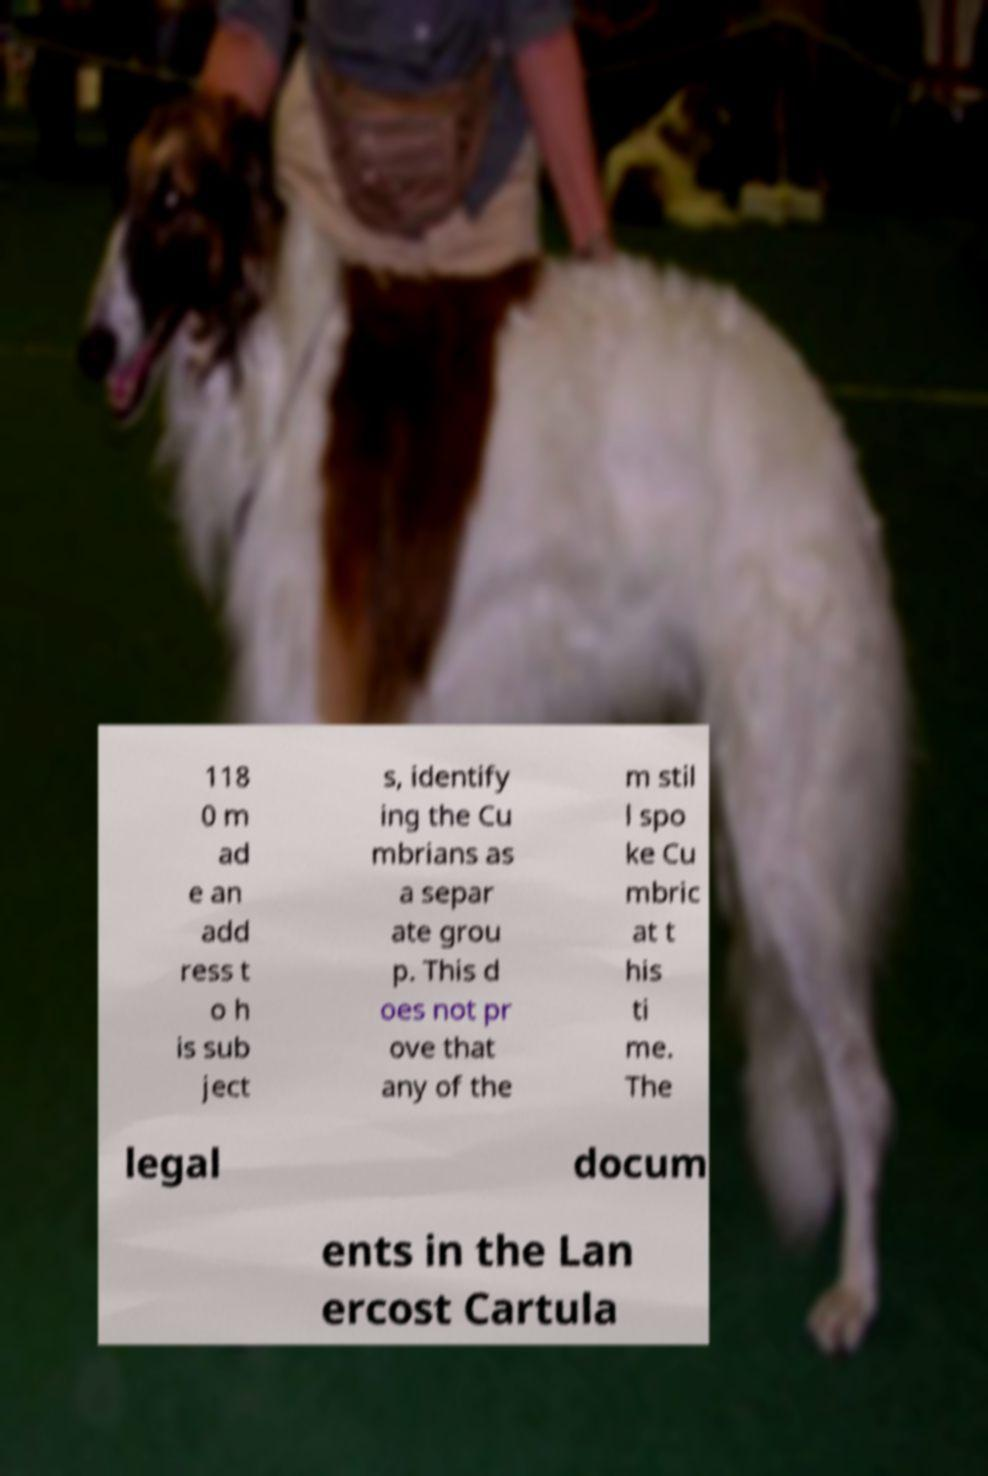Can you read and provide the text displayed in the image?This photo seems to have some interesting text. Can you extract and type it out for me? 118 0 m ad e an add ress t o h is sub ject s, identify ing the Cu mbrians as a separ ate grou p. This d oes not pr ove that any of the m stil l spo ke Cu mbric at t his ti me. The legal docum ents in the Lan ercost Cartula 